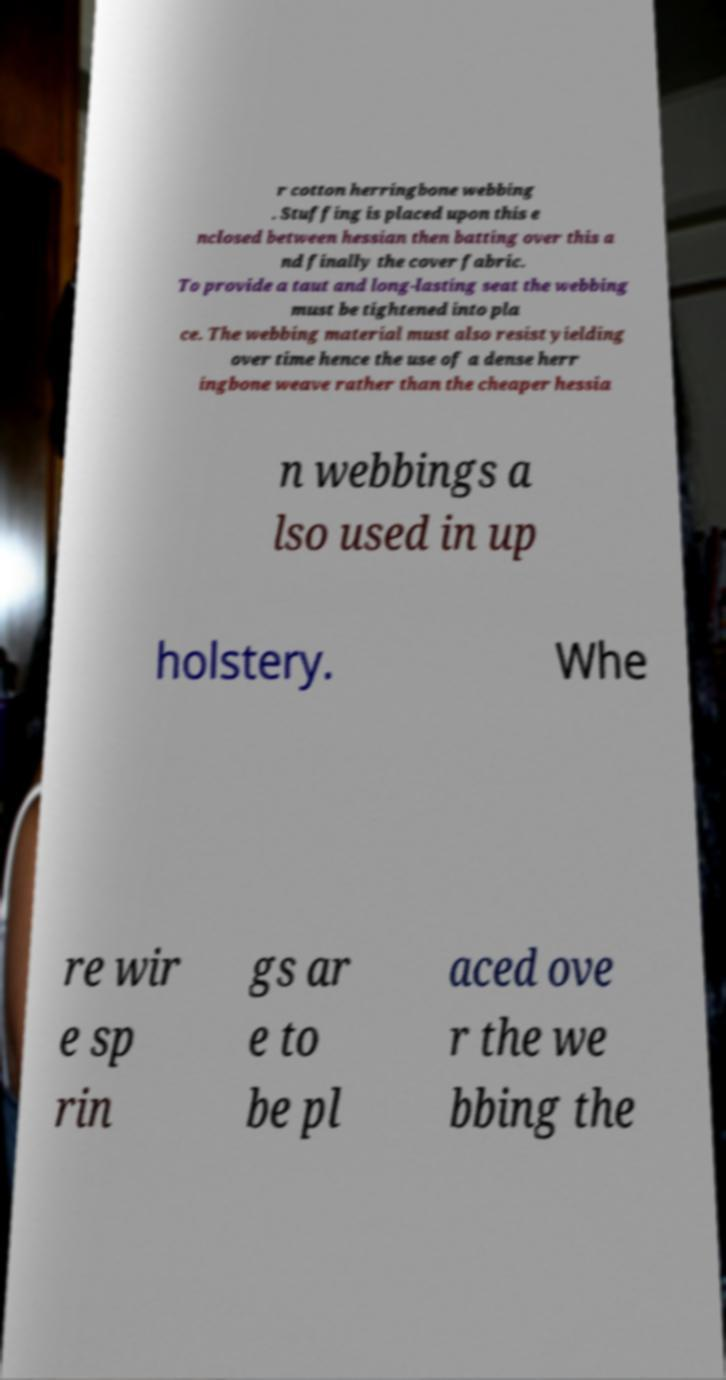Please read and relay the text visible in this image. What does it say? r cotton herringbone webbing . Stuffing is placed upon this e nclosed between hessian then batting over this a nd finally the cover fabric. To provide a taut and long-lasting seat the webbing must be tightened into pla ce. The webbing material must also resist yielding over time hence the use of a dense herr ingbone weave rather than the cheaper hessia n webbings a lso used in up holstery. Whe re wir e sp rin gs ar e to be pl aced ove r the we bbing the 